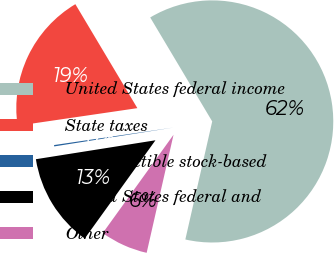Convert chart. <chart><loc_0><loc_0><loc_500><loc_500><pie_chart><fcel>United States federal income<fcel>State taxes<fcel>Nondeductible stock-based<fcel>United States federal and<fcel>Other<nl><fcel>62.12%<fcel>18.76%<fcel>0.18%<fcel>12.57%<fcel>6.37%<nl></chart> 